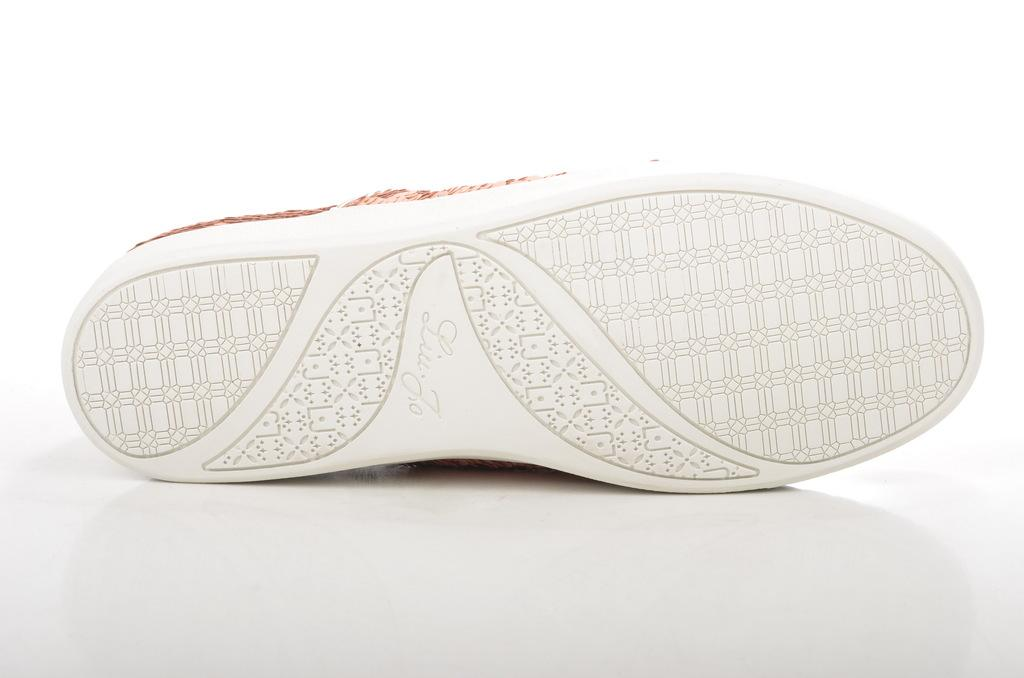What object is the main subject of the image? There is a shoe in the image. What colors can be seen on the shoe? The shoe is white and brown in color. Are there any words or symbols on the shoe? Yes, there is writing on the shoe. What is the shoe placed on in the image? The shoe is on a white surface. What type of soup is being prepared in the image? There is no soup present in the image; it features a shoe on a white surface. How is the whip being used in the image? There is no whip present in the image; it only shows a shoe with writing on it. 